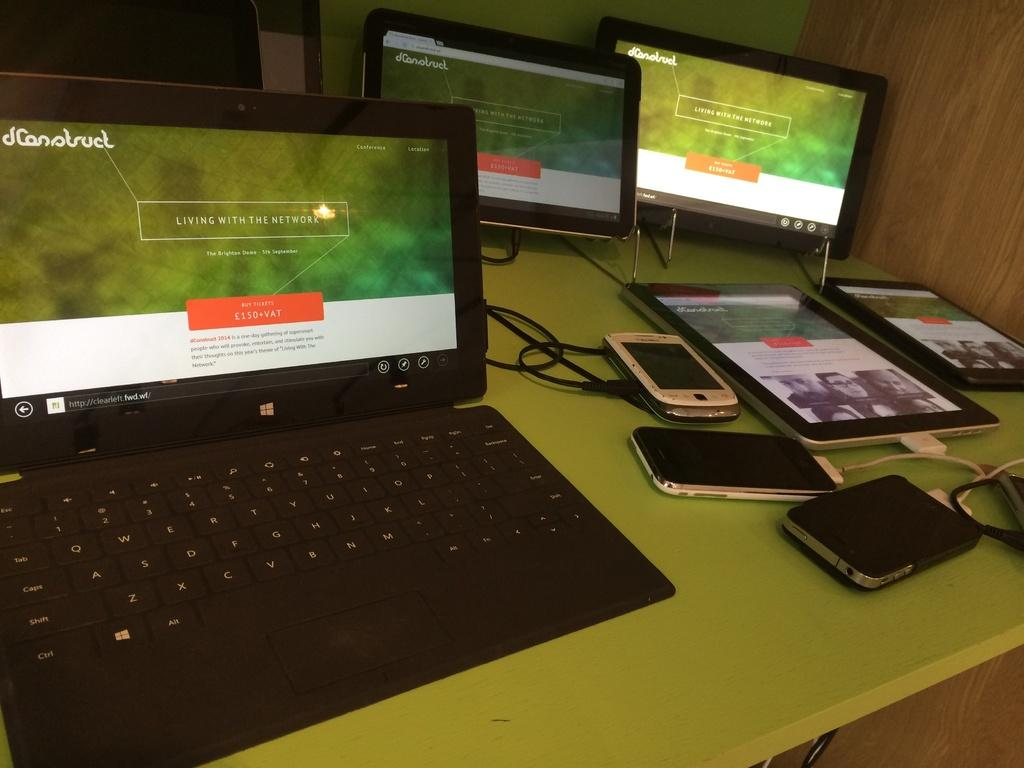What is the main piece of furniture in the image? There is a table in the image. What electronic devices are on the table? There are laptops and mobile phones on the table. Are there any other gadgets on the table besides laptops and mobile phones? Yes, there are other gadgets on the table. How many plants are on the table in the image? There are no plants visible on the table in the image. What type of rabbits can be seen interacting with the gadgets on the table? There are no rabbits present in the image; it only features electronic devices and other gadgets on the table. 